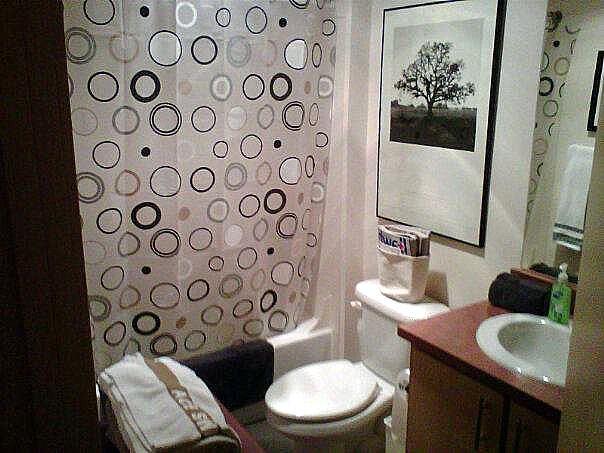Where is the floor mat?
Give a very brief answer. Bathtub. What is all over the shower curtain?
Give a very brief answer. Circles. What pattern is the shower curtain?
Keep it brief. Circles. What kind of room is this?
Answer briefly. Bathroom. Do you see a waste basket?
Concise answer only. No. 